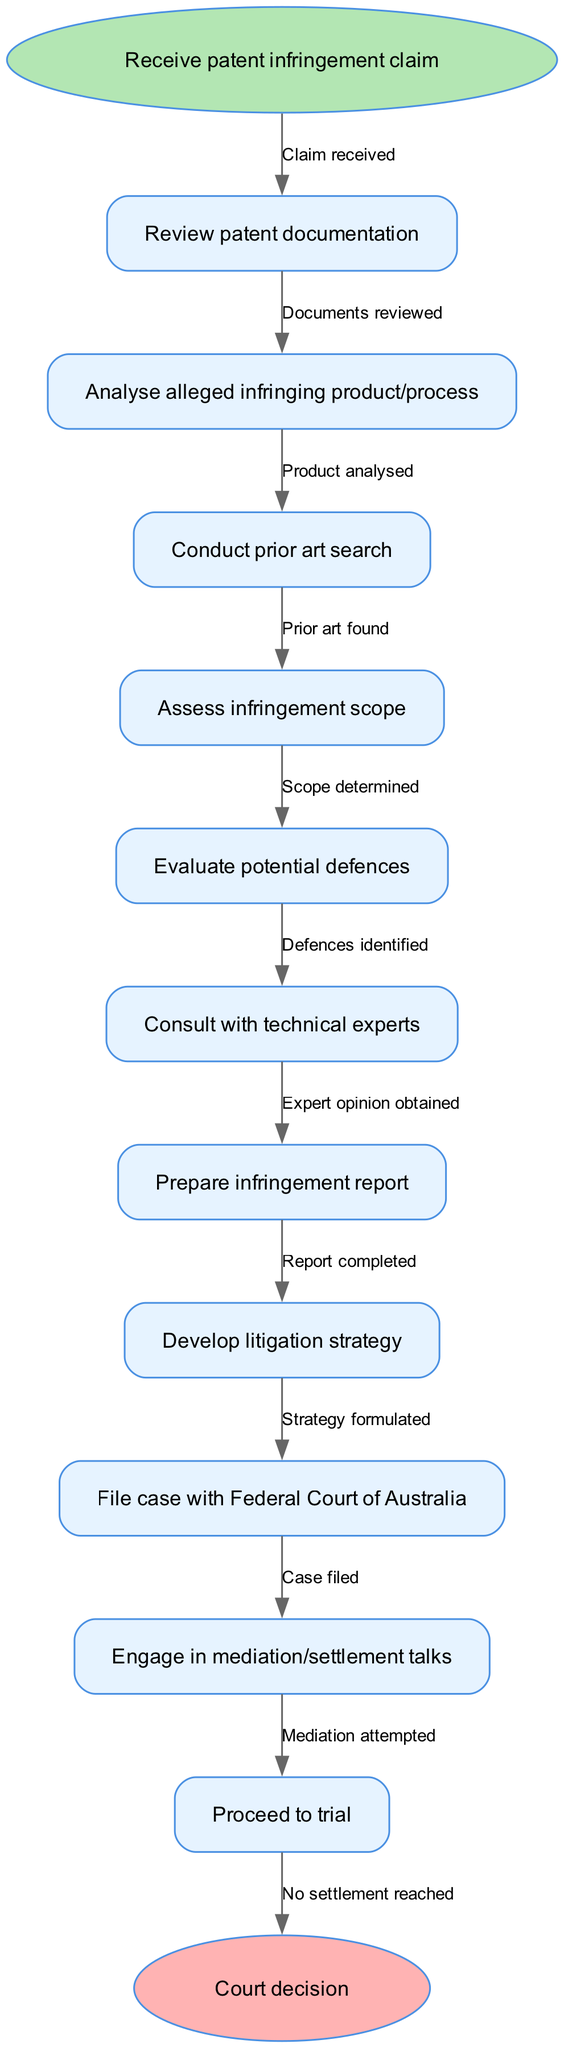What is the starting point of the flowchart? The starting point of the flowchart is "Receive patent infringement claim," which is represented in the diagram as the shape that begins the process. It is the first node before any other actions take place.
Answer: Receive patent infringement claim How many total nodes are in the flowchart? The flowchart contains a total of 12 nodes, including both starting and ending nodes as well as the intermediate process nodes defined in the diagram. These are counted to include the "start," the 10 process nodes, and the "end."
Answer: 12 What is the last step before reaching the court decision? The last step before reaching the court decision is "Proceed to trial." This node follows the actions leading up to the trial and precedes the court’s final determination of the case as shown in the flowchart.
Answer: Proceed to trial What action immediately follows the assessment of infringement scope? The action that immediately follows the assessment of infringement scope is "Evaluate potential defences." In the flowchart, this indicates the progression to consider possible defences after assessing the extent of infringement.
Answer: Evaluate potential defences How many edges are there connecting the nodes in the flowchart? There are 11 edges connecting the nodes in the flowchart, which correspond to the relationships between the actions represented by the nodes. Each edge signifies a transition from one action to another in the process layout.
Answer: 11 What is the purpose of consulting with technical experts in the flowchart? The purpose of consulting with technical experts is to obtain their opinion on the technical aspects of the alleged infringement. This step is crucial for informed decision-making regarding the case and further litigation strategy.
Answer: Obtain opinion What action is taken if mediation attempts do not result in a settlement? If mediation attempts do not result in a settlement, the flowchart indicates that the next action is "Proceed to trial." This step escalates the process from negotiation to formal litigation in court.
Answer: Proceed to trial What is the relationship between "Analyse alleged infringing product/process" and "Conduct prior art search"? The relationship is that "Analyse alleged infringing product/process" sequentially leads to "Conduct prior art search." This indicates the progression from analyzing the infringement to researching prior art, which is essential for building a case.
Answer: Sequentially leads to What is the final outcome of the flowchart before legal strategies are determined? The final outcome before legal strategies are determined is when the "Prepare infringement report" is completed. This report is crucial for summarizing findings and informing the subsequent strategic decisions related to the litigation.
Answer: Prepare infringement report 